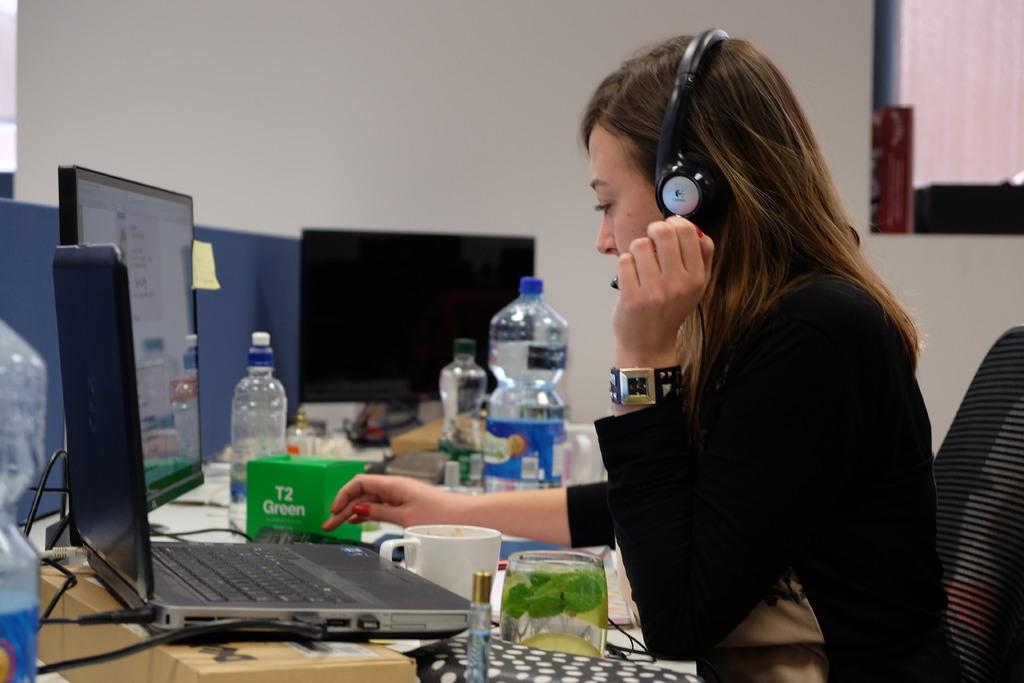<image>
Render a clear and concise summary of the photo. a lady uses a laptop next to a T2 Green box 